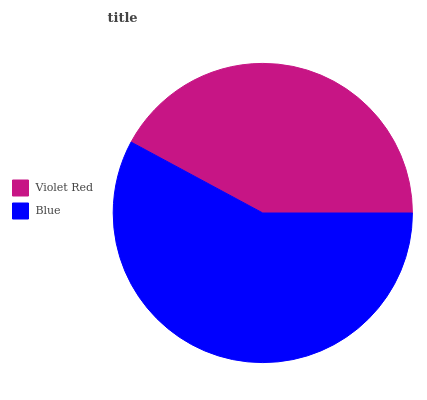Is Violet Red the minimum?
Answer yes or no. Yes. Is Blue the maximum?
Answer yes or no. Yes. Is Blue the minimum?
Answer yes or no. No. Is Blue greater than Violet Red?
Answer yes or no. Yes. Is Violet Red less than Blue?
Answer yes or no. Yes. Is Violet Red greater than Blue?
Answer yes or no. No. Is Blue less than Violet Red?
Answer yes or no. No. Is Blue the high median?
Answer yes or no. Yes. Is Violet Red the low median?
Answer yes or no. Yes. Is Violet Red the high median?
Answer yes or no. No. Is Blue the low median?
Answer yes or no. No. 